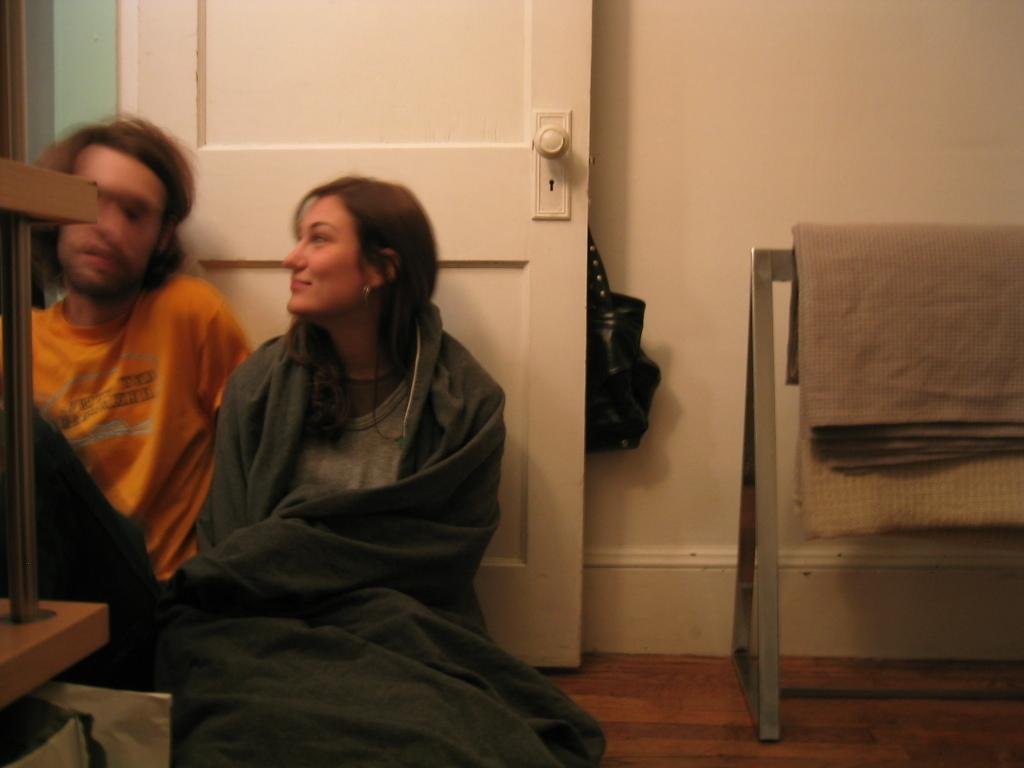What type of structure can be seen in the image? There is a wall in the image. What accessory is visible in the image? There is a black color handbag in the image. What feature is present in the wall? There is a door in the image. What material is visible in the image? There is cloth visible in the image. Where are the people located in the image? There are two people sitting on the left side of the image. How many snakes are crawling on the cloth in the image? There are no snakes present in the image; only a wall, a handbag, a door, cloth, and two people are visible. What type of pencil is being used by the people in the image? There is no pencil visible in the image; only a wall, a handbag, a door, cloth, and two people are present. 